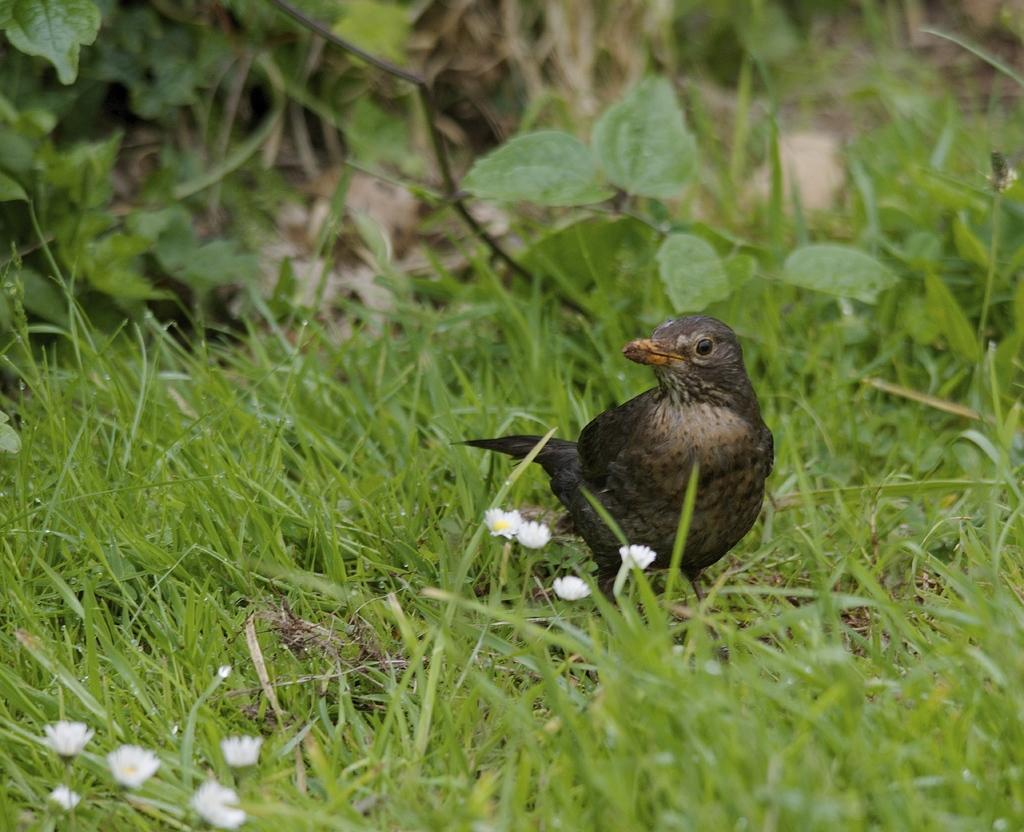What type of animal can be seen in the image? There is a bird in the image. Where is the bird located? The bird is standing on the grass. What type of lettuce is the bird eating in the image? There is no lettuce present in the image, and the bird is not shown eating anything. 